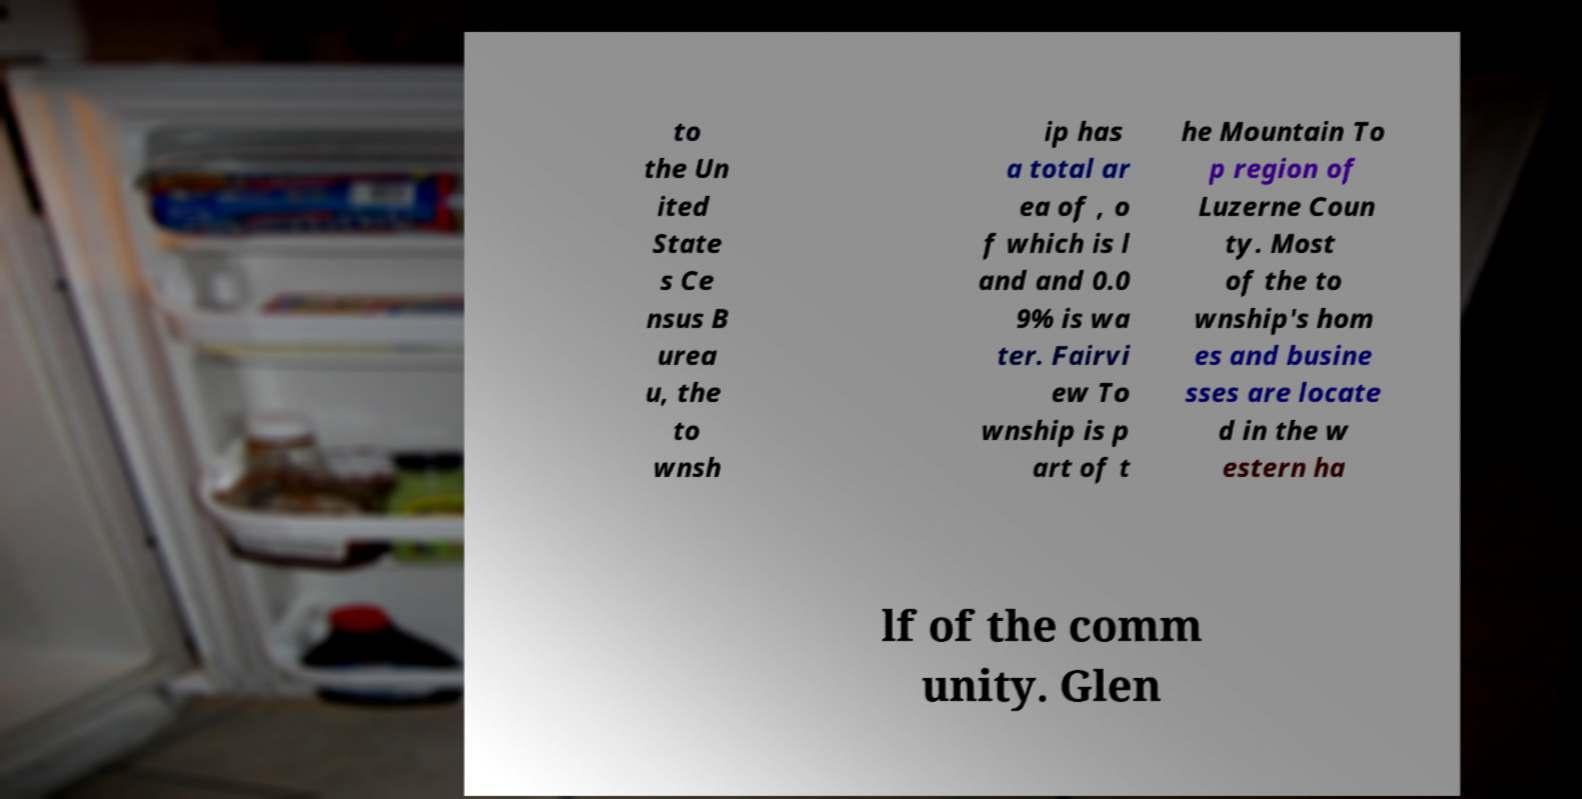Please identify and transcribe the text found in this image. to the Un ited State s Ce nsus B urea u, the to wnsh ip has a total ar ea of , o f which is l and and 0.0 9% is wa ter. Fairvi ew To wnship is p art of t he Mountain To p region of Luzerne Coun ty. Most of the to wnship's hom es and busine sses are locate d in the w estern ha lf of the comm unity. Glen 